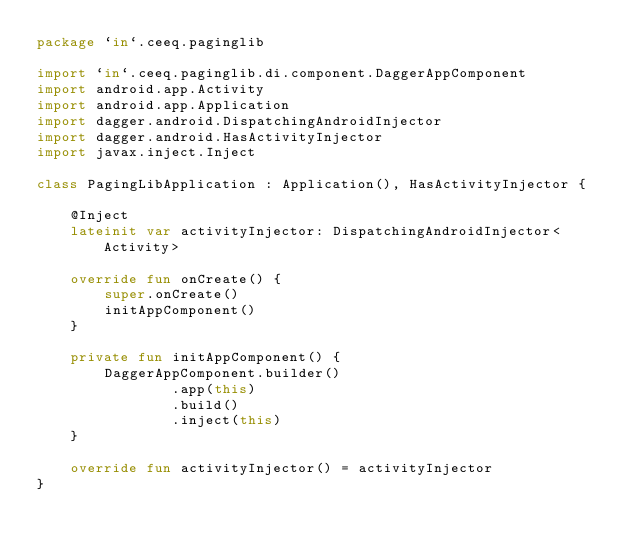<code> <loc_0><loc_0><loc_500><loc_500><_Kotlin_>package `in`.ceeq.paginglib

import `in`.ceeq.paginglib.di.component.DaggerAppComponent
import android.app.Activity
import android.app.Application
import dagger.android.DispatchingAndroidInjector
import dagger.android.HasActivityInjector
import javax.inject.Inject

class PagingLibApplication : Application(), HasActivityInjector {

    @Inject
    lateinit var activityInjector: DispatchingAndroidInjector<Activity>

    override fun onCreate() {
        super.onCreate()
        initAppComponent()
    }

    private fun initAppComponent() {
        DaggerAppComponent.builder()
                .app(this)
                .build()
                .inject(this)
    }

    override fun activityInjector() = activityInjector
}
</code> 